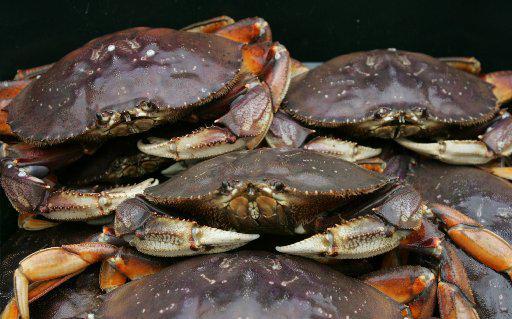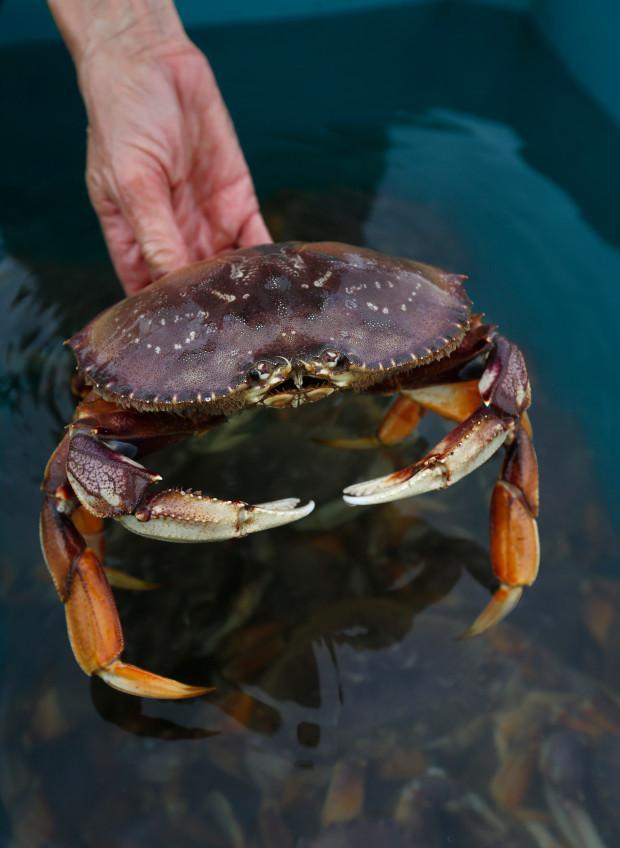The first image is the image on the left, the second image is the image on the right. Evaluate the accuracy of this statement regarding the images: "Each image contains exactly one prominent forward-facing crab, and no image contains a part of a human.". Is it true? Answer yes or no. No. The first image is the image on the left, the second image is the image on the right. Evaluate the accuracy of this statement regarding the images: "The left and right image contains the same number of sea animals.". Is it true? Answer yes or no. No. 